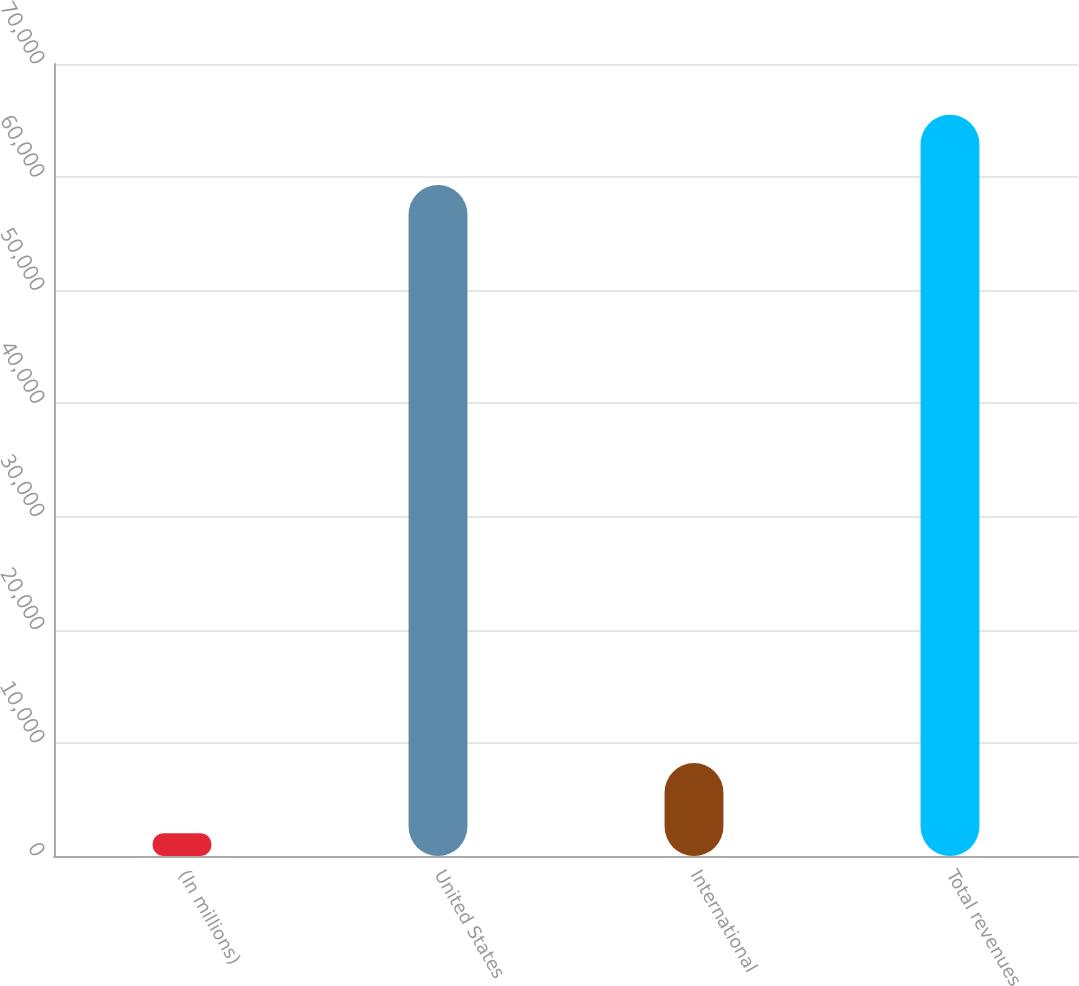<chart> <loc_0><loc_0><loc_500><loc_500><bar_chart><fcel>(In millions)<fcel>United States<fcel>International<fcel>Total revenues<nl><fcel>2007<fcel>59302<fcel>8215.9<fcel>65510.9<nl></chart> 